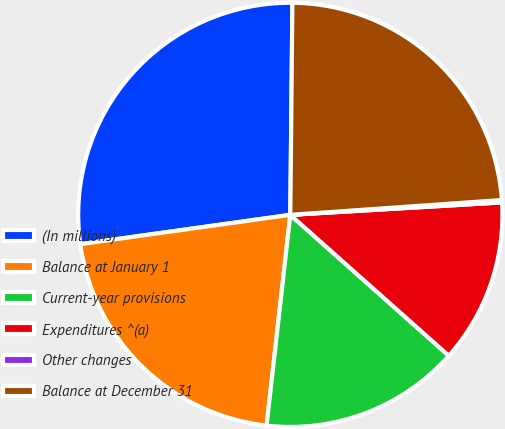Convert chart. <chart><loc_0><loc_0><loc_500><loc_500><pie_chart><fcel>(In millions)<fcel>Balance at January 1<fcel>Current-year provisions<fcel>Expenditures ^(a)<fcel>Other changes<fcel>Balance at December 31<nl><fcel>27.37%<fcel>21.01%<fcel>15.22%<fcel>12.5%<fcel>0.18%<fcel>23.73%<nl></chart> 